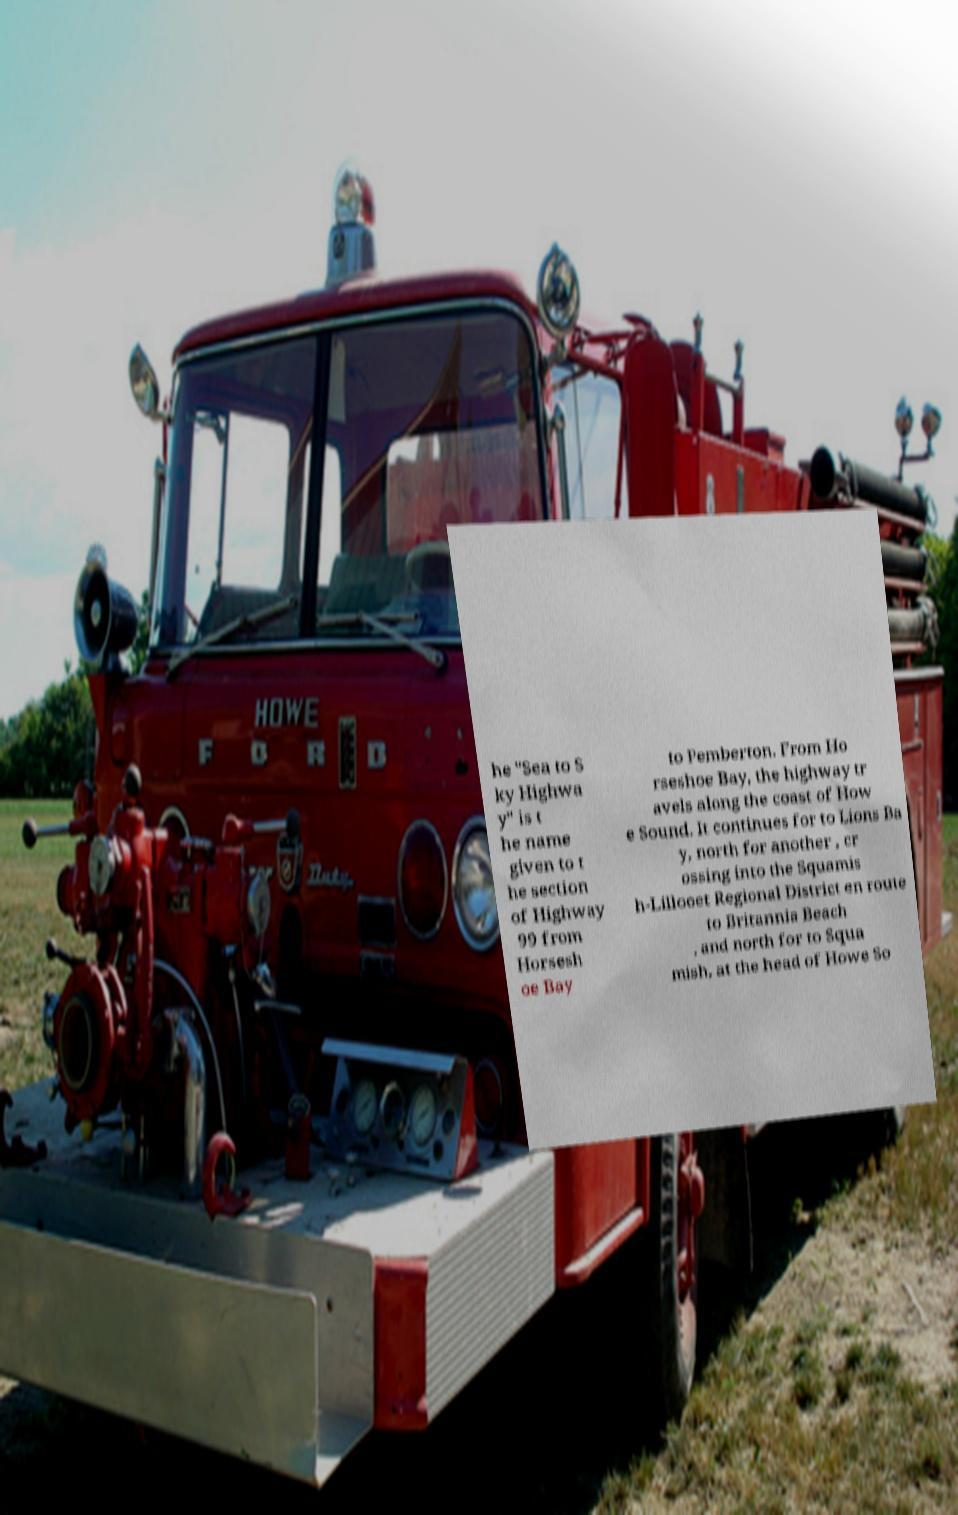Could you extract and type out the text from this image? he "Sea to S ky Highwa y" is t he name given to t he section of Highway 99 from Horsesh oe Bay to Pemberton. From Ho rseshoe Bay, the highway tr avels along the coast of How e Sound. It continues for to Lions Ba y, north for another , cr ossing into the Squamis h-Lillooet Regional District en route to Britannia Beach , and north for to Squa mish, at the head of Howe So 